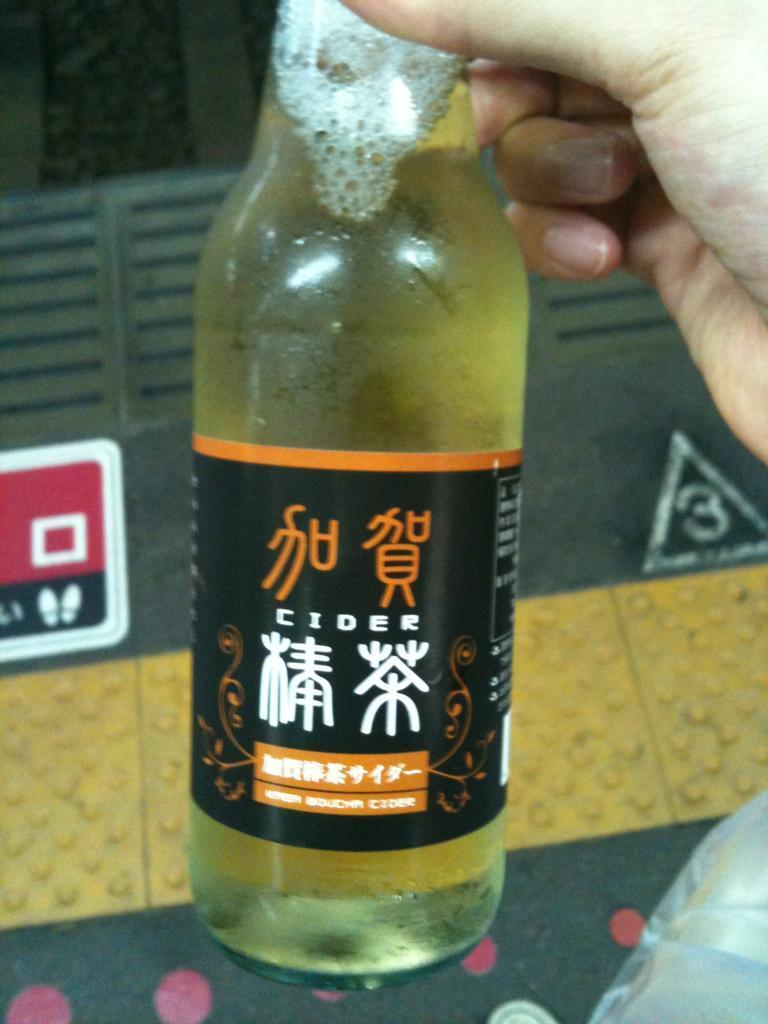<image>
Write a terse but informative summary of the picture. A person holding a bottle of cider with Chinese writing on the label. 